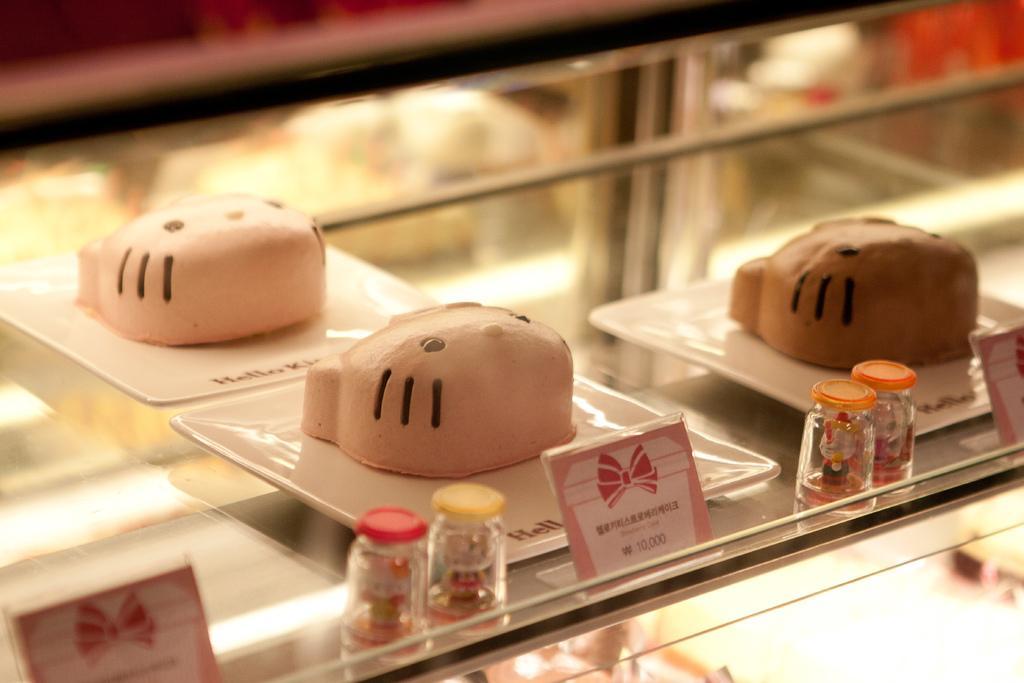Describe this image in one or two sentences. There is a glass rack. On that there are trays. On the trays there are cakes in the shape of cat face. Also there are some small bottles and some price tags. 